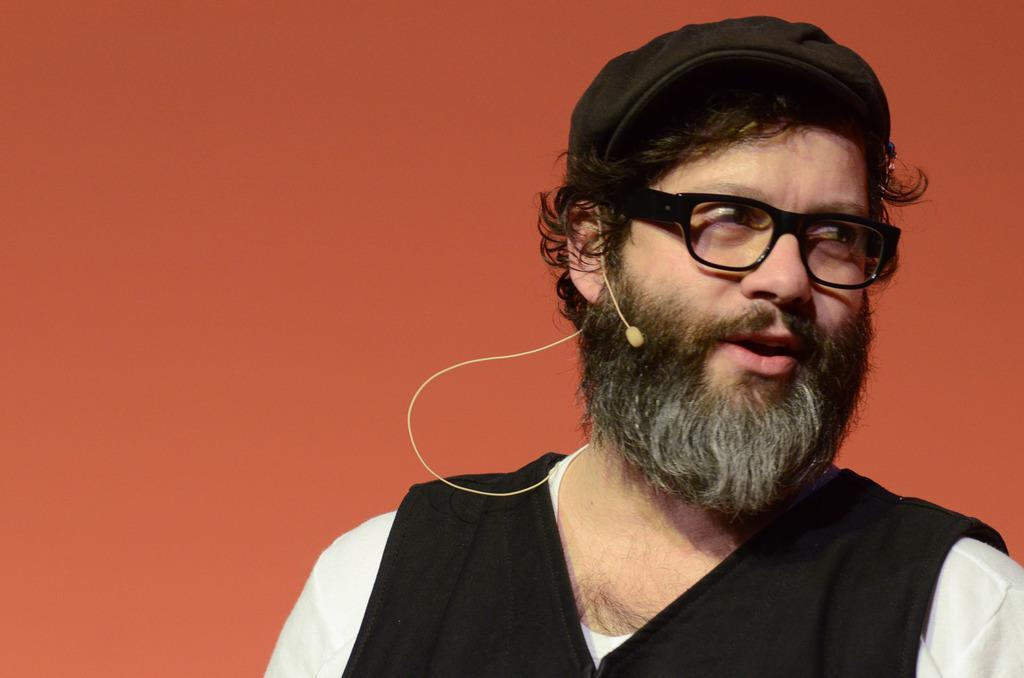Could you give a brief overview of what you see in this image? In this picture, there is a man towards the right. He is wearing black jacket,white t shirt, spectacles and a micro phone and the background is in orange. 